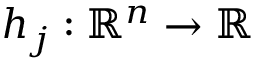Convert formula to latex. <formula><loc_0><loc_0><loc_500><loc_500>h _ { j } \colon \, \mathbb { R } ^ { n } \rightarrow \mathbb { R }</formula> 